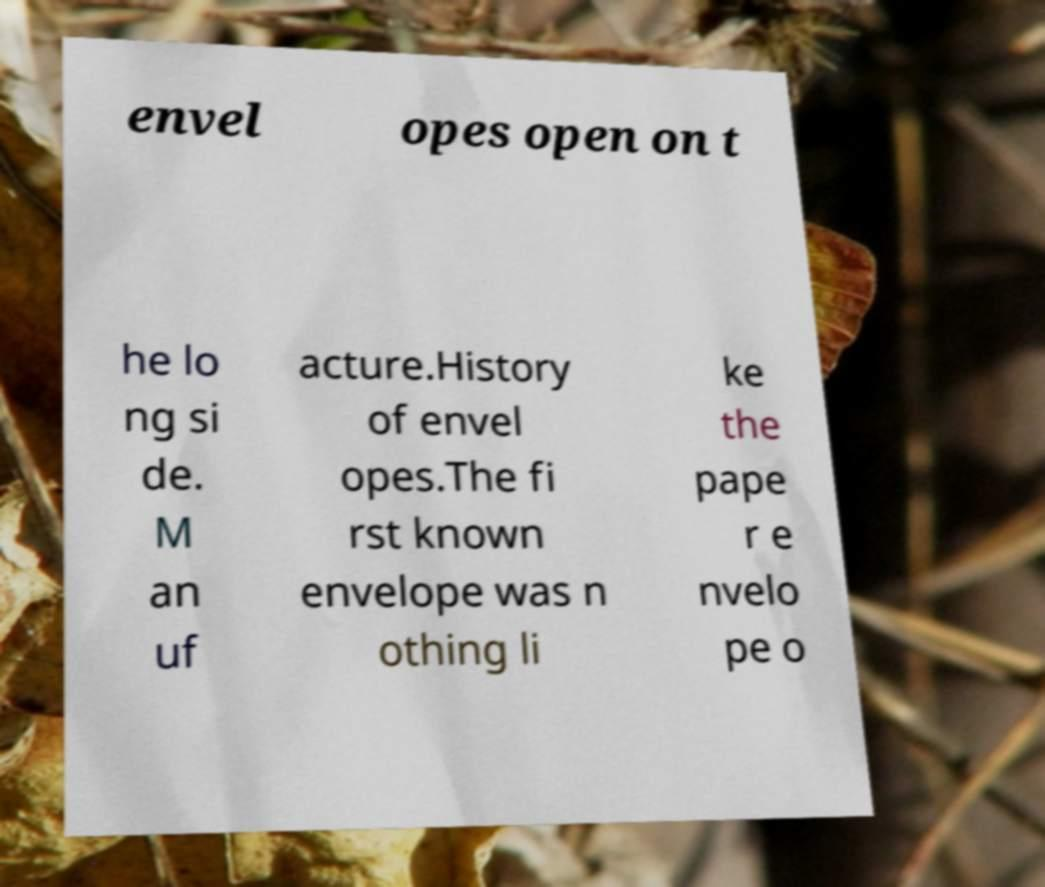Can you accurately transcribe the text from the provided image for me? envel opes open on t he lo ng si de. M an uf acture.History of envel opes.The fi rst known envelope was n othing li ke the pape r e nvelo pe o 